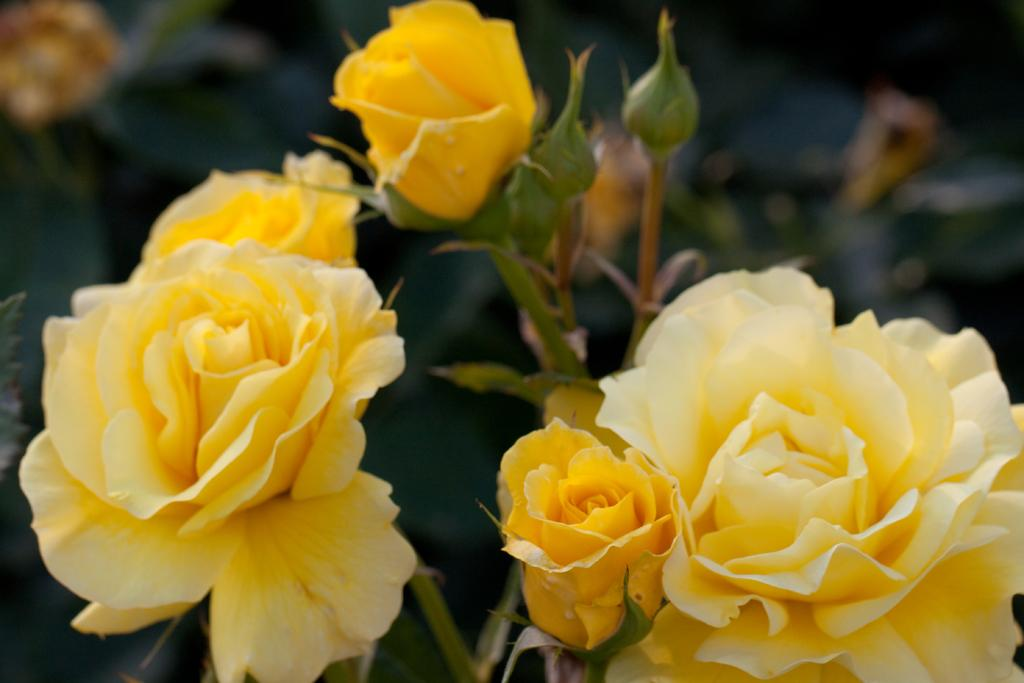What type of plants are in the image? There are flowers in the image. What color are the flowers? The flowers are yellow in color. What parts of the flowers are visible in the image? The flowers have stems and buds. How would you describe the background of the image? The background of the image is blurred. What type of plastic material can be seen in the image? There is no plastic material present in the image. What event related to death is depicted in the image? There is no event related to death depicted in the image; it features flowers with stems and buds. 